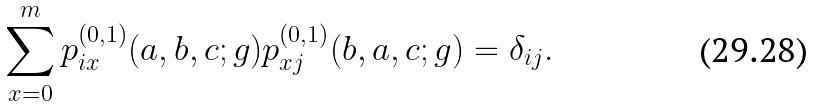Convert formula to latex. <formula><loc_0><loc_0><loc_500><loc_500>\sum _ { x = 0 } ^ { m } p _ { i x } ^ { ( 0 , 1 ) } ( a , b , c ; g ) p _ { x j } ^ { ( 0 , 1 ) } ( b , a , c ; g ) = \delta _ { i j } .</formula> 